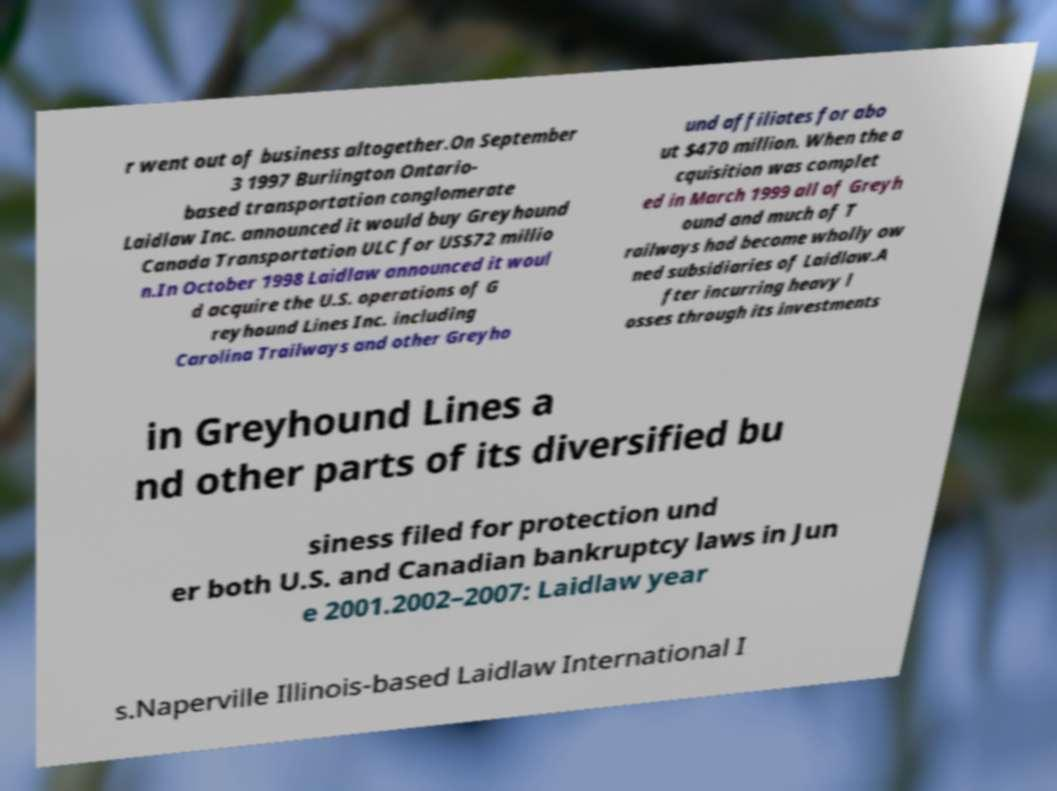I need the written content from this picture converted into text. Can you do that? r went out of business altogether.On September 3 1997 Burlington Ontario- based transportation conglomerate Laidlaw Inc. announced it would buy Greyhound Canada Transportation ULC for US$72 millio n.In October 1998 Laidlaw announced it woul d acquire the U.S. operations of G reyhound Lines Inc. including Carolina Trailways and other Greyho und affiliates for abo ut $470 million. When the a cquisition was complet ed in March 1999 all of Greyh ound and much of T railways had become wholly ow ned subsidiaries of Laidlaw.A fter incurring heavy l osses through its investments in Greyhound Lines a nd other parts of its diversified bu siness filed for protection und er both U.S. and Canadian bankruptcy laws in Jun e 2001.2002–2007: Laidlaw year s.Naperville Illinois-based Laidlaw International I 